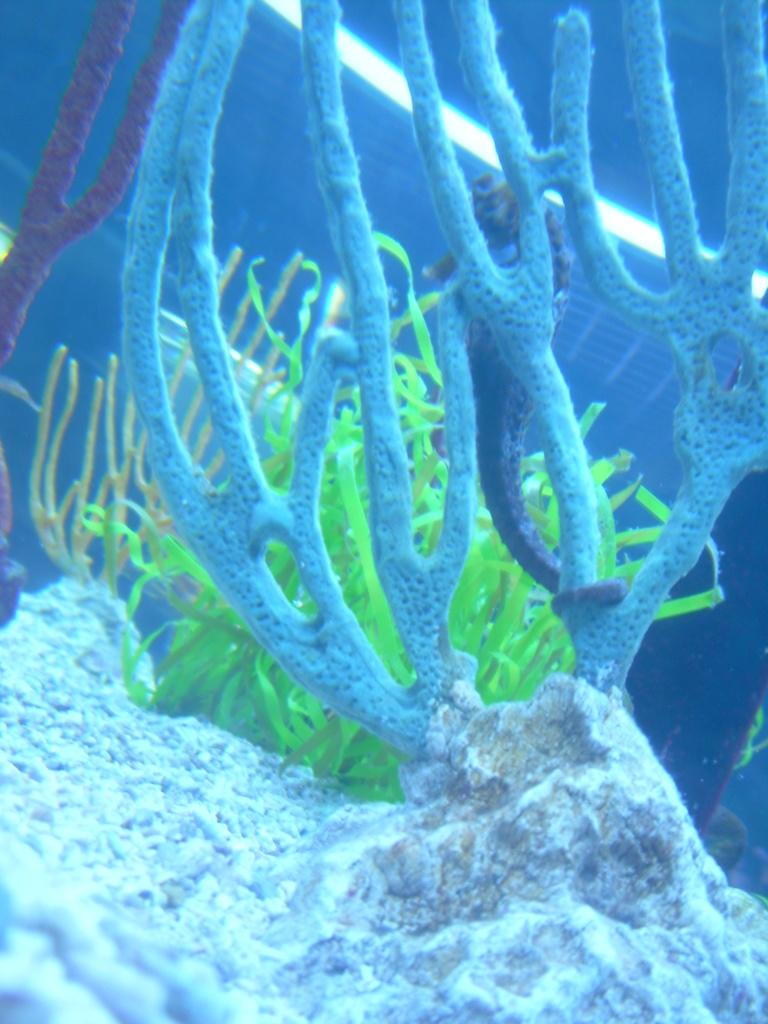What type of plants are visible in the image? There are aquatic plants in the image. What other object can be seen in the image besides the plants? There is a stone in the image. What colors are present in the aquatic plants and stone? The colors present in the aquatic plants and stone are white, blue, and green. Can you tell me how many oranges are on the stone in the image? A: There are no oranges present in the image; the stone and aquatic plants have colors of white, blue, and green. 